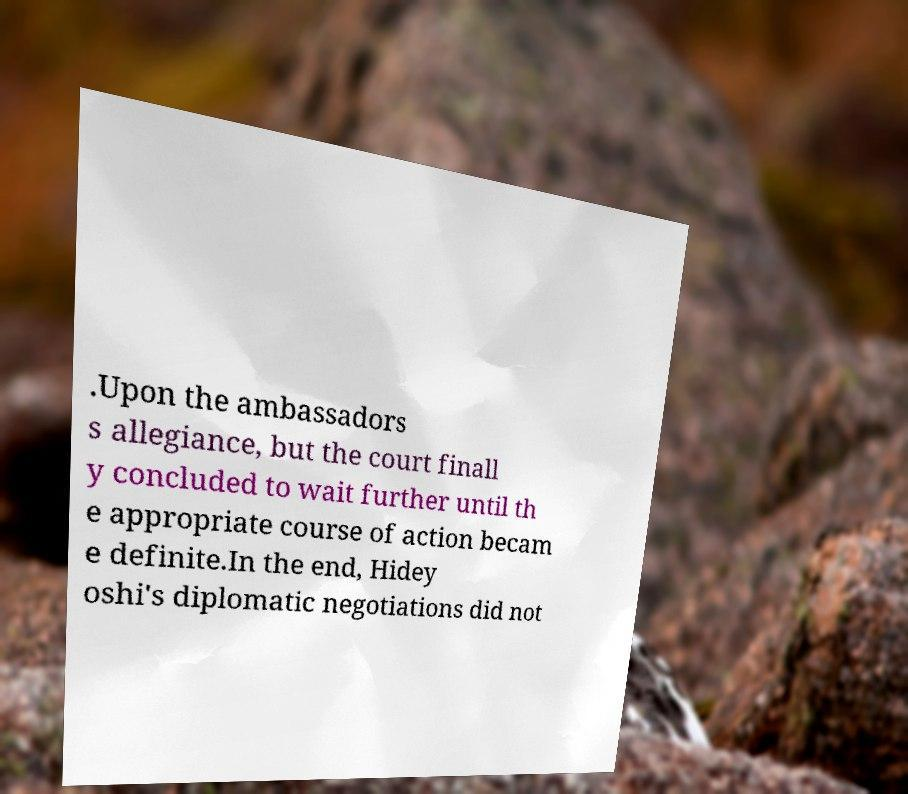Please read and relay the text visible in this image. What does it say? .Upon the ambassadors s allegiance, but the court finall y concluded to wait further until th e appropriate course of action becam e definite.In the end, Hidey oshi's diplomatic negotiations did not 